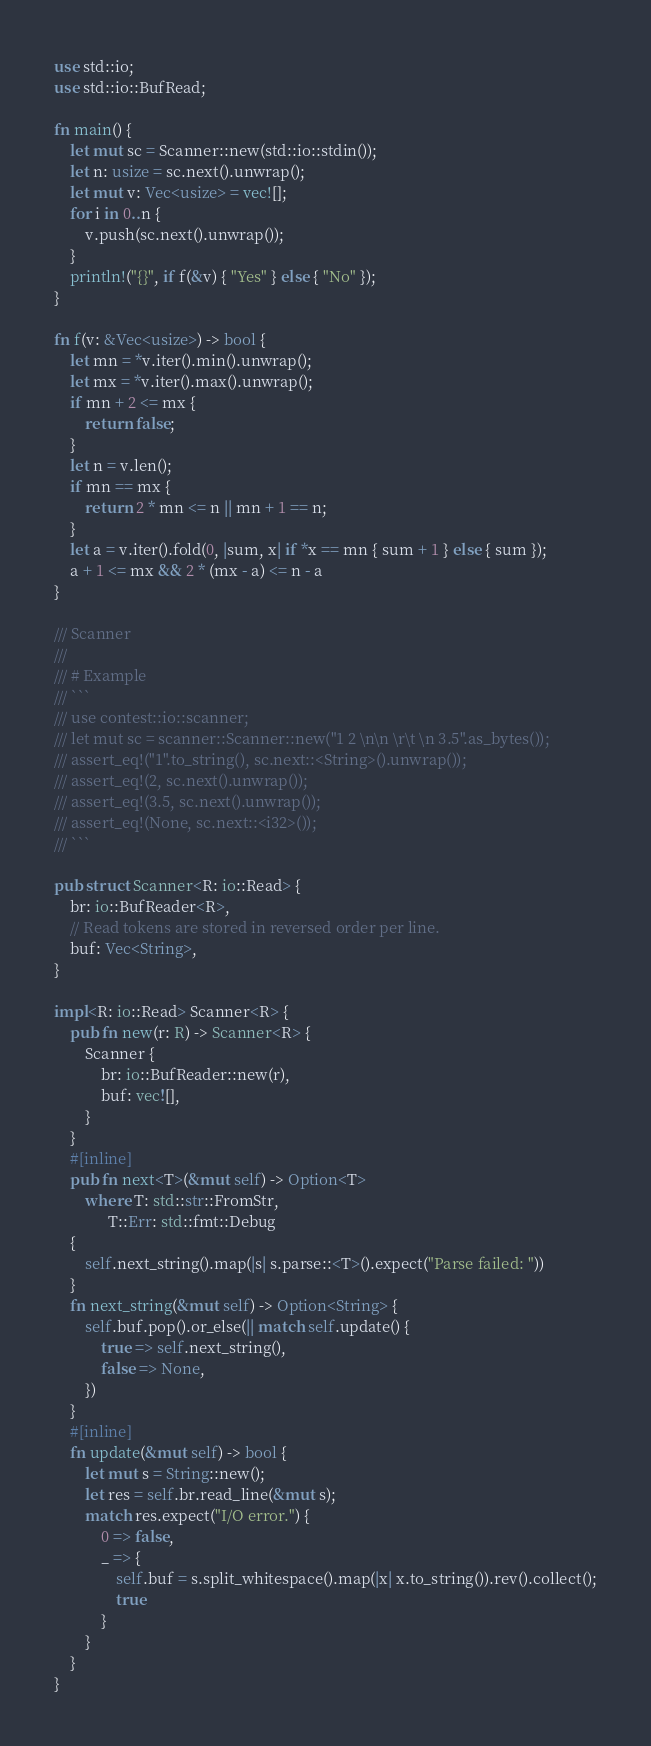<code> <loc_0><loc_0><loc_500><loc_500><_Rust_>use std::io;
use std::io::BufRead;

fn main() {
    let mut sc = Scanner::new(std::io::stdin());
    let n: usize = sc.next().unwrap();
    let mut v: Vec<usize> = vec![];
    for i in 0..n {
        v.push(sc.next().unwrap());
    }
    println!("{}", if f(&v) { "Yes" } else { "No" });
}

fn f(v: &Vec<usize>) -> bool {
    let mn = *v.iter().min().unwrap();
    let mx = *v.iter().max().unwrap();
    if mn + 2 <= mx {
        return false;
    }
    let n = v.len();
    if mn == mx {
        return 2 * mn <= n || mn + 1 == n;
    }
    let a = v.iter().fold(0, |sum, x| if *x == mn { sum + 1 } else { sum });
    a + 1 <= mx && 2 * (mx - a) <= n - a
}

/// Scanner
///
/// # Example
/// ```
/// use contest::io::scanner;
/// let mut sc = scanner::Scanner::new("1 2 \n\n \r\t \n 3.5".as_bytes());
/// assert_eq!("1".to_string(), sc.next::<String>().unwrap());
/// assert_eq!(2, sc.next().unwrap());
/// assert_eq!(3.5, sc.next().unwrap());
/// assert_eq!(None, sc.next::<i32>());
/// ```

pub struct Scanner<R: io::Read> {
    br: io::BufReader<R>,
    // Read tokens are stored in reversed order per line.
    buf: Vec<String>,
}

impl<R: io::Read> Scanner<R> {
    pub fn new(r: R) -> Scanner<R> {
        Scanner {
            br: io::BufReader::new(r),
            buf: vec![],
        }
    }
    #[inline]
    pub fn next<T>(&mut self) -> Option<T>
        where T: std::str::FromStr,
              T::Err: std::fmt::Debug
    {
        self.next_string().map(|s| s.parse::<T>().expect("Parse failed: "))
    }
    fn next_string(&mut self) -> Option<String> {
        self.buf.pop().or_else(|| match self.update() {
            true => self.next_string(),
            false => None,
        })
    }
    #[inline]
    fn update(&mut self) -> bool {
        let mut s = String::new();
        let res = self.br.read_line(&mut s);
        match res.expect("I/O error.") {
            0 => false,
            _ => {
                self.buf = s.split_whitespace().map(|x| x.to_string()).rev().collect();
                true
            }
        }
    }
}
</code> 